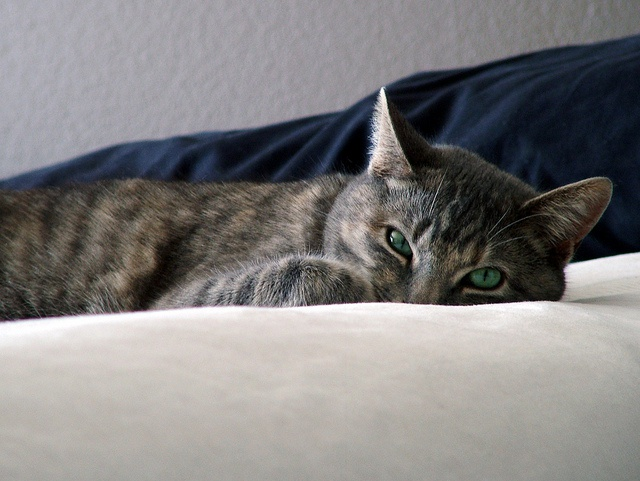Describe the objects in this image and their specific colors. I can see bed in darkgray, black, and lightgray tones and cat in darkgray, black, and gray tones in this image. 